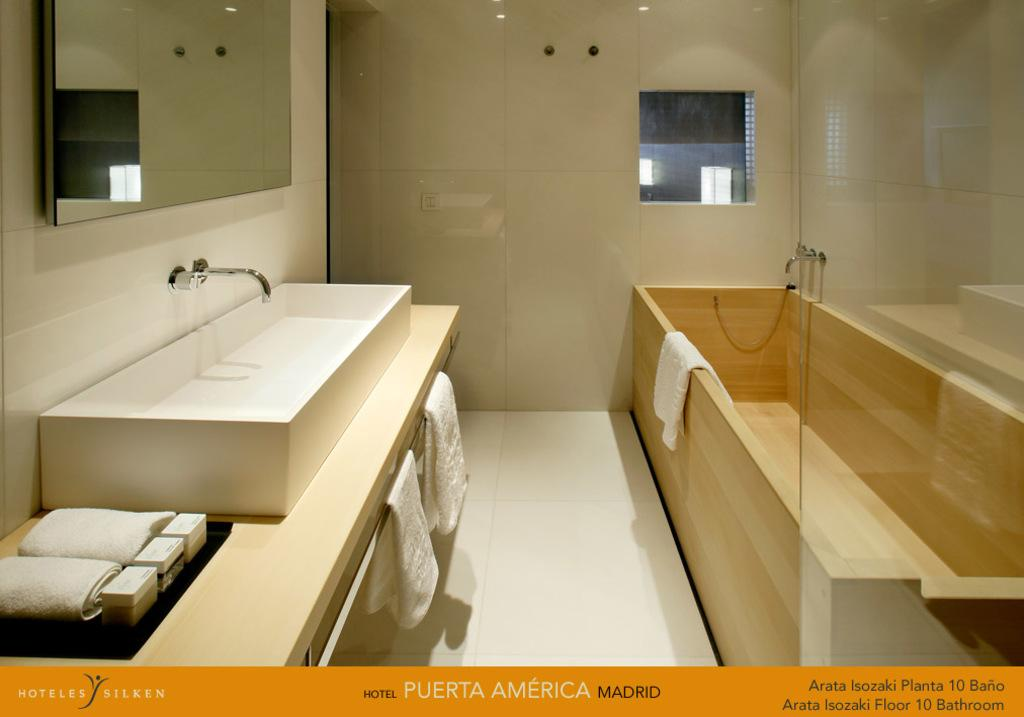What type of room is depicted in the image? The image shows the inner view of a washroom. What can be seen on the wall in the washroom? There is a mirror on the wall in the washroom. What is present for washing hands in the washroom? There is a sink and a tap in the washroom. What can be used for drying hands in the washroom? There are towels in the washroom. What are the walls made of in the washroom? The washroom has walls, but the material is not specified in the image. How can one enter or exit the washroom? There is a door in the washroom. What is another feature for bathing in the washroom? There is a bathtub in the washroom. What type of cattle can be seen grazing in the bathtub in the image? There is no cattle present in the image, and the bathtub is empty. What channel can be seen on the television in the washroom? There is no television present in the image. 